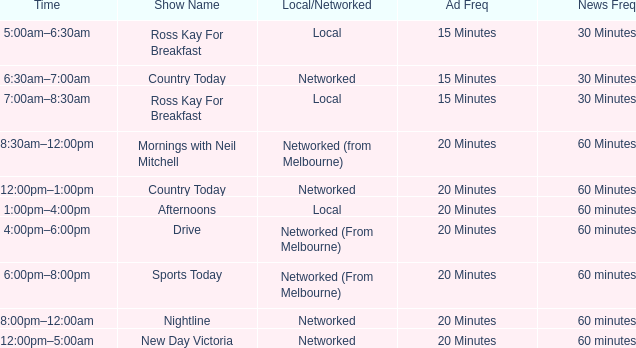What ad freq possesses a news freq of 60 minutes, and a local/networked of local? 20 Minutes. 